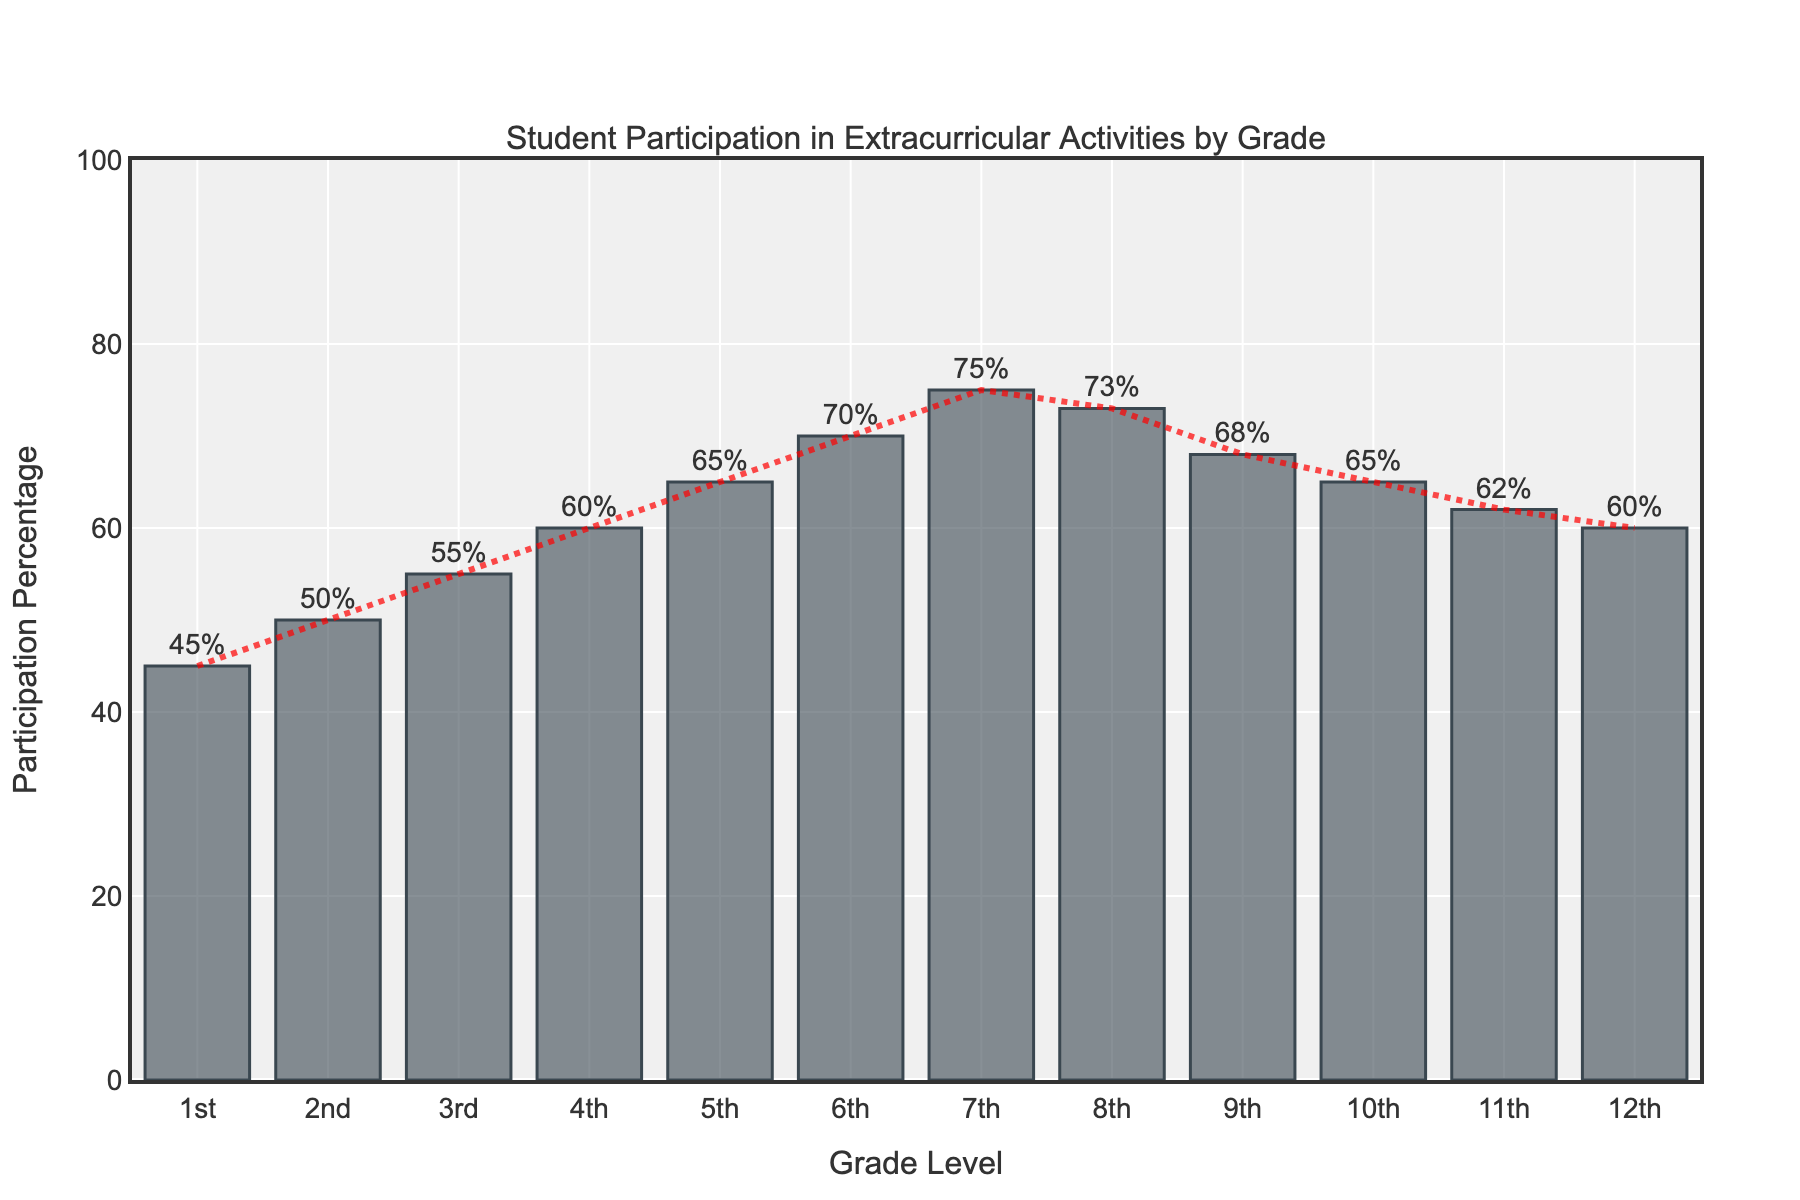What grade has the highest percentage of students participating in extracurricular activities? The grade with the highest bar in the chart represents the highest percentage of students participating in extracurricular activities. 7th grade has the highest bar.
Answer: 7th What is the difference between the percentages of students participating in extracurricular activities in 1st grade and 12th grade? The percentage for 1st grade is 45% and for 12th grade is 60%. The difference is calculated as 60% - 45%.
Answer: 15% For which grades is the percentage of participation equal? Look for grades sharing the same height of bars; both 4th and 12th grades have the same percentage of 60%.
Answer: 4th and 12th What is the average percentage of student participation from 1st grade to 3rd grade? Calculate the average by adding the percentages (45% + 50% + 55%) and then dividing by the number of grades (3). Therefore, (45 + 50 + 55) / 3 = 150 / 3.
Answer: 50% By how much does student participation increase from 1st grade to 7th grade? The percentage for 1st grade is 45% and for 7th grade is 75%. The increase is calculated as 75% - 45%.
Answer: 30% Which grade shows the first decline in student participation from a previous grade? Examine the trend line and bars from left to right to find the first instance where a bar is shorter than the one before it. The participation declines from 8th grade (73%) to 9th grade (68%).
Answer: 9th Is the percentage of student participation in 10th grade greater than or equal to that of 3rd grade? Compare the heights of the bars for 3rd grade (55%) and 10th grade (65%).
Answer: Yes What is the total participation percentage for grades 6th, 7th, and 8th combined? Add the percentages from these grades: 70% (6th) + 75% (7th) + 73% (8th). Therefore, 70 + 75 + 73.
Answer: 218% How does the trend of participation change from 8th grade to 12th grade? Observe the trend line and bar heights from 8th grade (73%) to 12th grade (60%). The overall trend is decreasing.
Answer: Decreasing What is the median percentage of participation across all grades? List the percentages in order: 45%, 50%, 55%, 60%, 60%, 62%, 65%, 65%, 68%, 70%, 73%, 75%. The median is the average of the 6th and 7th values in this sorted list: (62% + 65%) / 2.
Answer: 63.5% 